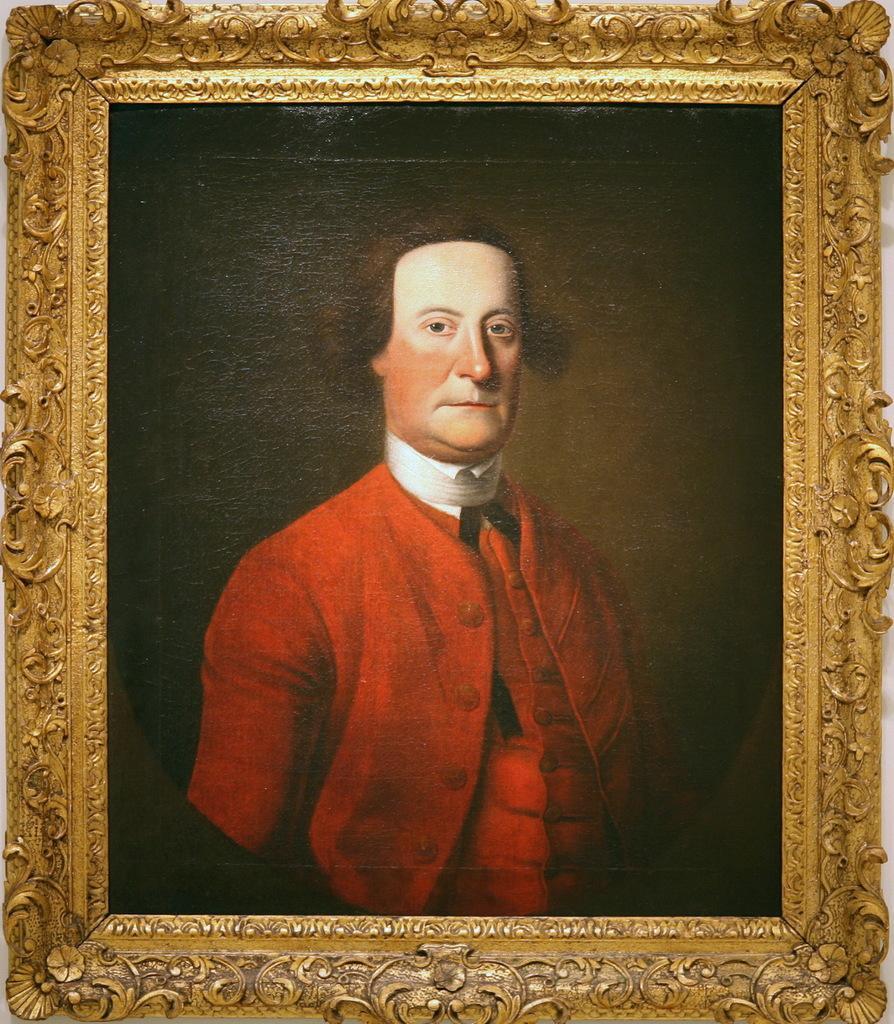Can you describe this image briefly? In this image I can see a frame which consists of a photograph of a man. This man is wearing a red color dress and looking at the picture. The background is dark. 